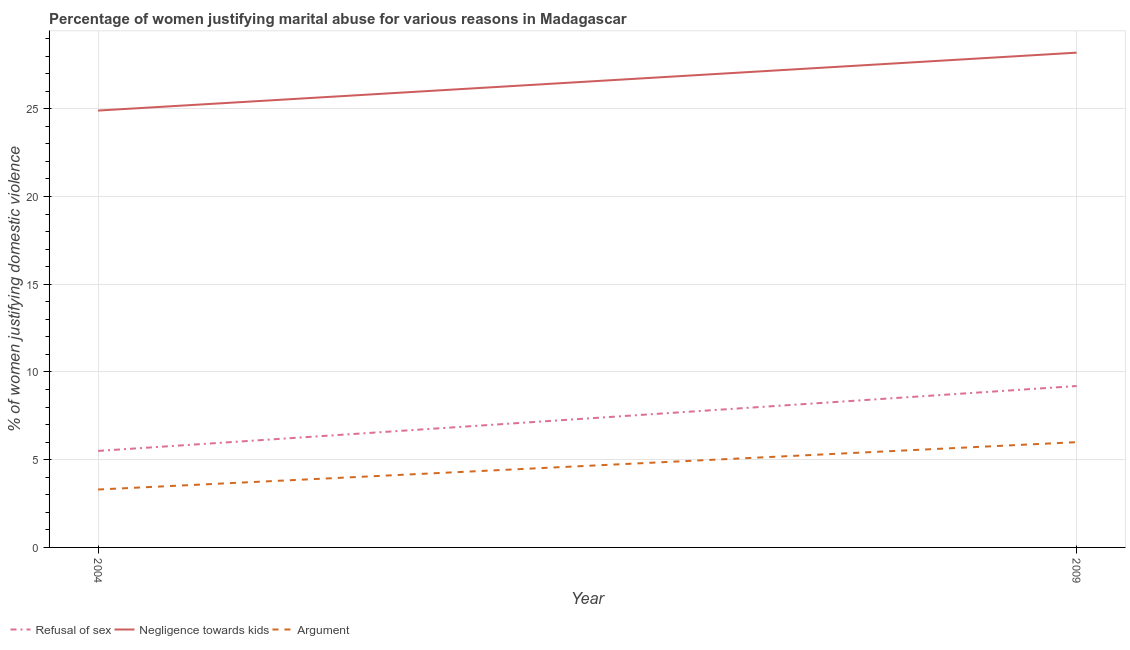How many different coloured lines are there?
Give a very brief answer. 3. Does the line corresponding to percentage of women justifying domestic violence due to negligence towards kids intersect with the line corresponding to percentage of women justifying domestic violence due to refusal of sex?
Your response must be concise. No. Is the number of lines equal to the number of legend labels?
Offer a very short reply. Yes. Across all years, what is the maximum percentage of women justifying domestic violence due to refusal of sex?
Your response must be concise. 9.2. In which year was the percentage of women justifying domestic violence due to arguments maximum?
Make the answer very short. 2009. What is the total percentage of women justifying domestic violence due to negligence towards kids in the graph?
Provide a short and direct response. 53.1. What is the difference between the percentage of women justifying domestic violence due to arguments in 2004 and that in 2009?
Provide a short and direct response. -2.7. What is the difference between the percentage of women justifying domestic violence due to arguments in 2004 and the percentage of women justifying domestic violence due to negligence towards kids in 2009?
Provide a succinct answer. -24.9. What is the average percentage of women justifying domestic violence due to negligence towards kids per year?
Keep it short and to the point. 26.55. In the year 2004, what is the difference between the percentage of women justifying domestic violence due to negligence towards kids and percentage of women justifying domestic violence due to refusal of sex?
Give a very brief answer. 19.4. What is the ratio of the percentage of women justifying domestic violence due to arguments in 2004 to that in 2009?
Your response must be concise. 0.55. In how many years, is the percentage of women justifying domestic violence due to arguments greater than the average percentage of women justifying domestic violence due to arguments taken over all years?
Your response must be concise. 1. Is it the case that in every year, the sum of the percentage of women justifying domestic violence due to refusal of sex and percentage of women justifying domestic violence due to negligence towards kids is greater than the percentage of women justifying domestic violence due to arguments?
Offer a terse response. Yes. How many lines are there?
Your response must be concise. 3. Does the graph contain any zero values?
Your answer should be compact. No. Where does the legend appear in the graph?
Ensure brevity in your answer.  Bottom left. How are the legend labels stacked?
Offer a terse response. Horizontal. What is the title of the graph?
Your answer should be very brief. Percentage of women justifying marital abuse for various reasons in Madagascar. Does "Capital account" appear as one of the legend labels in the graph?
Provide a succinct answer. No. What is the label or title of the Y-axis?
Provide a succinct answer. % of women justifying domestic violence. What is the % of women justifying domestic violence of Negligence towards kids in 2004?
Your answer should be compact. 24.9. What is the % of women justifying domestic violence in Refusal of sex in 2009?
Keep it short and to the point. 9.2. What is the % of women justifying domestic violence of Negligence towards kids in 2009?
Your answer should be very brief. 28.2. Across all years, what is the maximum % of women justifying domestic violence of Negligence towards kids?
Provide a short and direct response. 28.2. Across all years, what is the minimum % of women justifying domestic violence of Refusal of sex?
Your answer should be very brief. 5.5. Across all years, what is the minimum % of women justifying domestic violence of Negligence towards kids?
Your response must be concise. 24.9. Across all years, what is the minimum % of women justifying domestic violence in Argument?
Make the answer very short. 3.3. What is the total % of women justifying domestic violence of Refusal of sex in the graph?
Your response must be concise. 14.7. What is the total % of women justifying domestic violence of Negligence towards kids in the graph?
Offer a very short reply. 53.1. What is the difference between the % of women justifying domestic violence of Argument in 2004 and that in 2009?
Offer a terse response. -2.7. What is the difference between the % of women justifying domestic violence of Refusal of sex in 2004 and the % of women justifying domestic violence of Negligence towards kids in 2009?
Provide a short and direct response. -22.7. What is the difference between the % of women justifying domestic violence in Negligence towards kids in 2004 and the % of women justifying domestic violence in Argument in 2009?
Keep it short and to the point. 18.9. What is the average % of women justifying domestic violence of Refusal of sex per year?
Make the answer very short. 7.35. What is the average % of women justifying domestic violence in Negligence towards kids per year?
Your answer should be compact. 26.55. What is the average % of women justifying domestic violence in Argument per year?
Keep it short and to the point. 4.65. In the year 2004, what is the difference between the % of women justifying domestic violence in Refusal of sex and % of women justifying domestic violence in Negligence towards kids?
Your response must be concise. -19.4. In the year 2004, what is the difference between the % of women justifying domestic violence in Negligence towards kids and % of women justifying domestic violence in Argument?
Your answer should be very brief. 21.6. In the year 2009, what is the difference between the % of women justifying domestic violence in Refusal of sex and % of women justifying domestic violence in Negligence towards kids?
Provide a succinct answer. -19. What is the ratio of the % of women justifying domestic violence in Refusal of sex in 2004 to that in 2009?
Your response must be concise. 0.6. What is the ratio of the % of women justifying domestic violence in Negligence towards kids in 2004 to that in 2009?
Your answer should be compact. 0.88. What is the ratio of the % of women justifying domestic violence of Argument in 2004 to that in 2009?
Make the answer very short. 0.55. What is the difference between the highest and the second highest % of women justifying domestic violence of Negligence towards kids?
Provide a short and direct response. 3.3. What is the difference between the highest and the lowest % of women justifying domestic violence in Refusal of sex?
Offer a terse response. 3.7. What is the difference between the highest and the lowest % of women justifying domestic violence of Negligence towards kids?
Ensure brevity in your answer.  3.3. What is the difference between the highest and the lowest % of women justifying domestic violence of Argument?
Provide a short and direct response. 2.7. 